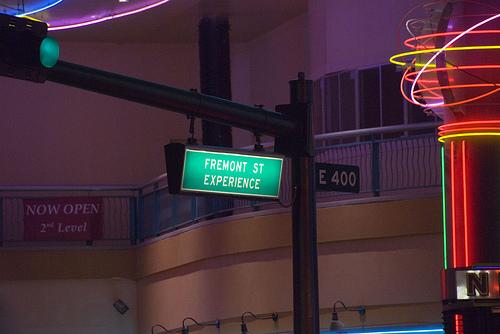Is this a shopping mall?
Answer briefly. Yes. What is the name of the street?
Be succinct. Fremont. Are the lights colored?
Quick response, please. Yes. 